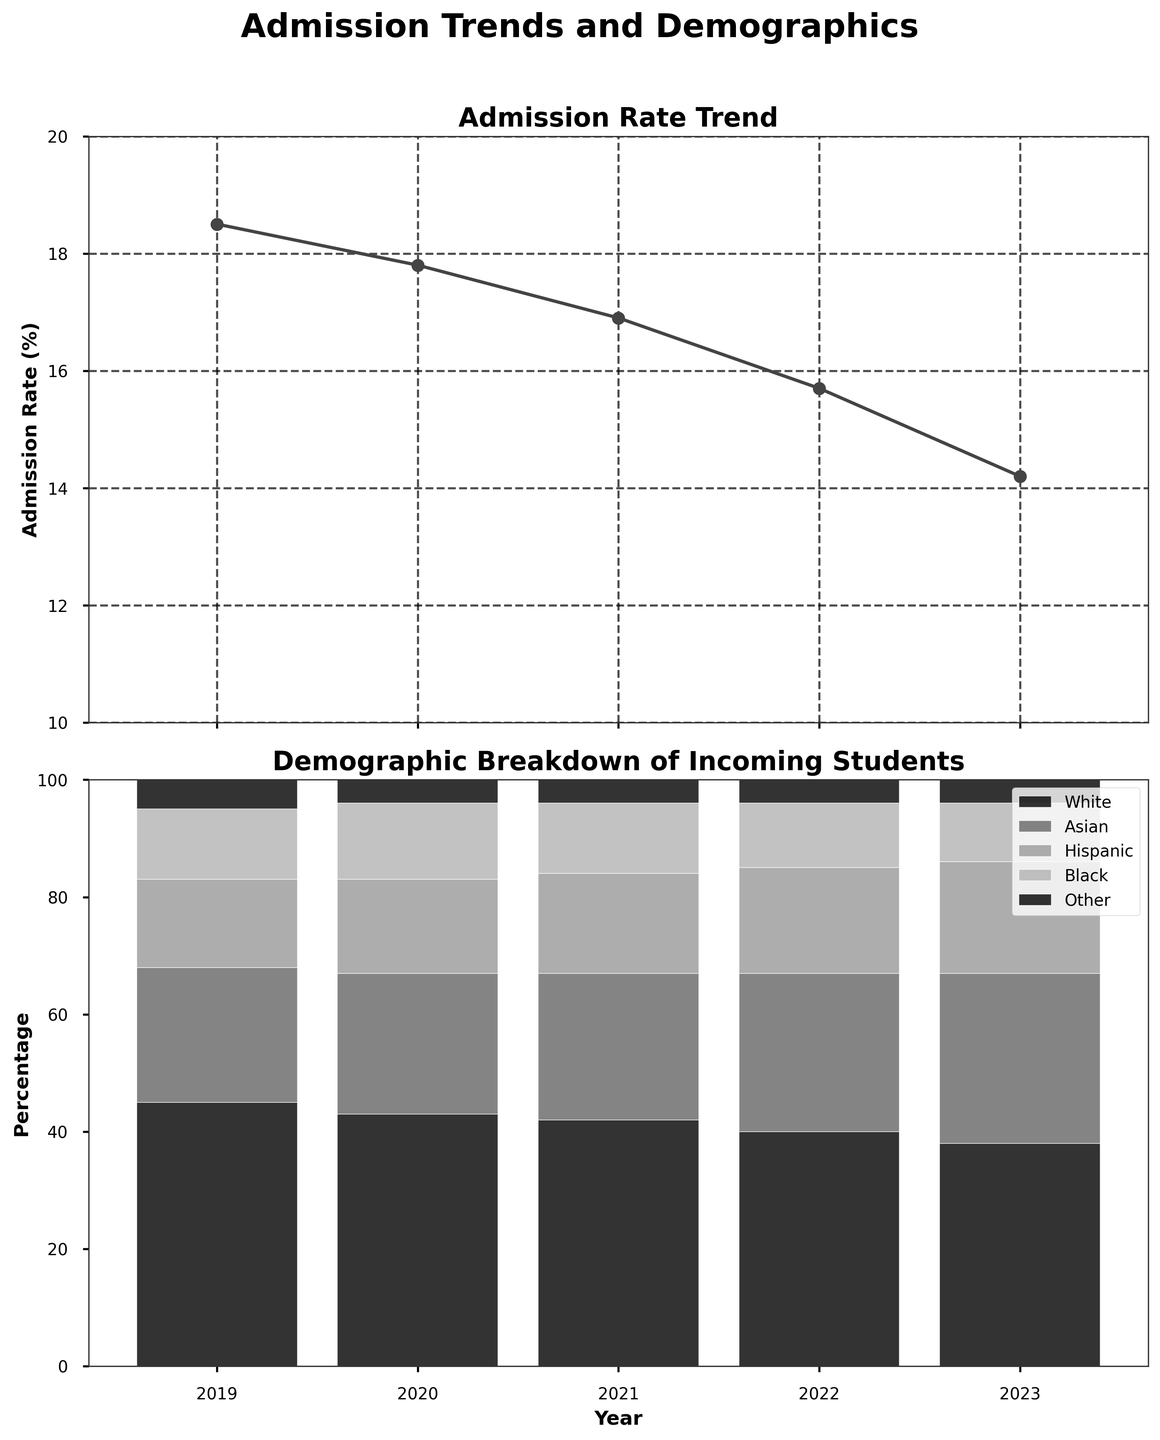What is the admission rate in 2023? The admission rate for each year is represented by the line plot in the top subplot. By locating the point for the year 2023, we see that it is 14.2%.
Answer: 14.2% Which demographic group saw the largest increase in percentage from 2019 to 2023? The bar plot in the bottom subplot shows the demographic breakdown for each year. Comparing the bar segments from 2019 to 2023 for each group, the Asian category increased the most from 23% to 29%, a 6% increase.
Answer: Asian What is the sum of the percentages for Hispanic and Black students in 2021? In 2021, the percentage for Hispanic students is 17% and for Black students is 12%. Adding these together, the sum is 17% + 12% = 29%.
Answer: 29% Between which two consecutive years did the admission rate drop the most? Observing the line plot on the top subplot for consecutive years, the admission rate drops from 15.7% in 2022 to 14.2% in 2023. The drop is 15.7% - 14.2% = 1.5%, which is the largest drop between years.
Answer: 2022 and 2023 Did the percentage of White students increase or decrease over the years? The bar plot in the bottom subplot shows the percentage of White students decreasing from 45% in 2019 to 38% in 2023.
Answer: Decrease How much did the admission rate decrease from 2019 to 2023? In 2019, the admission rate was 18.5%, and in 2023, it was 14.2%. The decrease is 18.5% - 14.2% = 4.3%.
Answer: 4.3% Which demographic had the most stable percentage over the years? Checking all demographic bars in the bottom subplot, 'Other' remained constant at approximately 4-5% each year, showing the most stability.
Answer: Other What is the overall trend in admission rates over the past 5 years? The line plot on the top subplot shows a downward trend in admission rates from 2019 to 2023.
Answer: Downward trend 